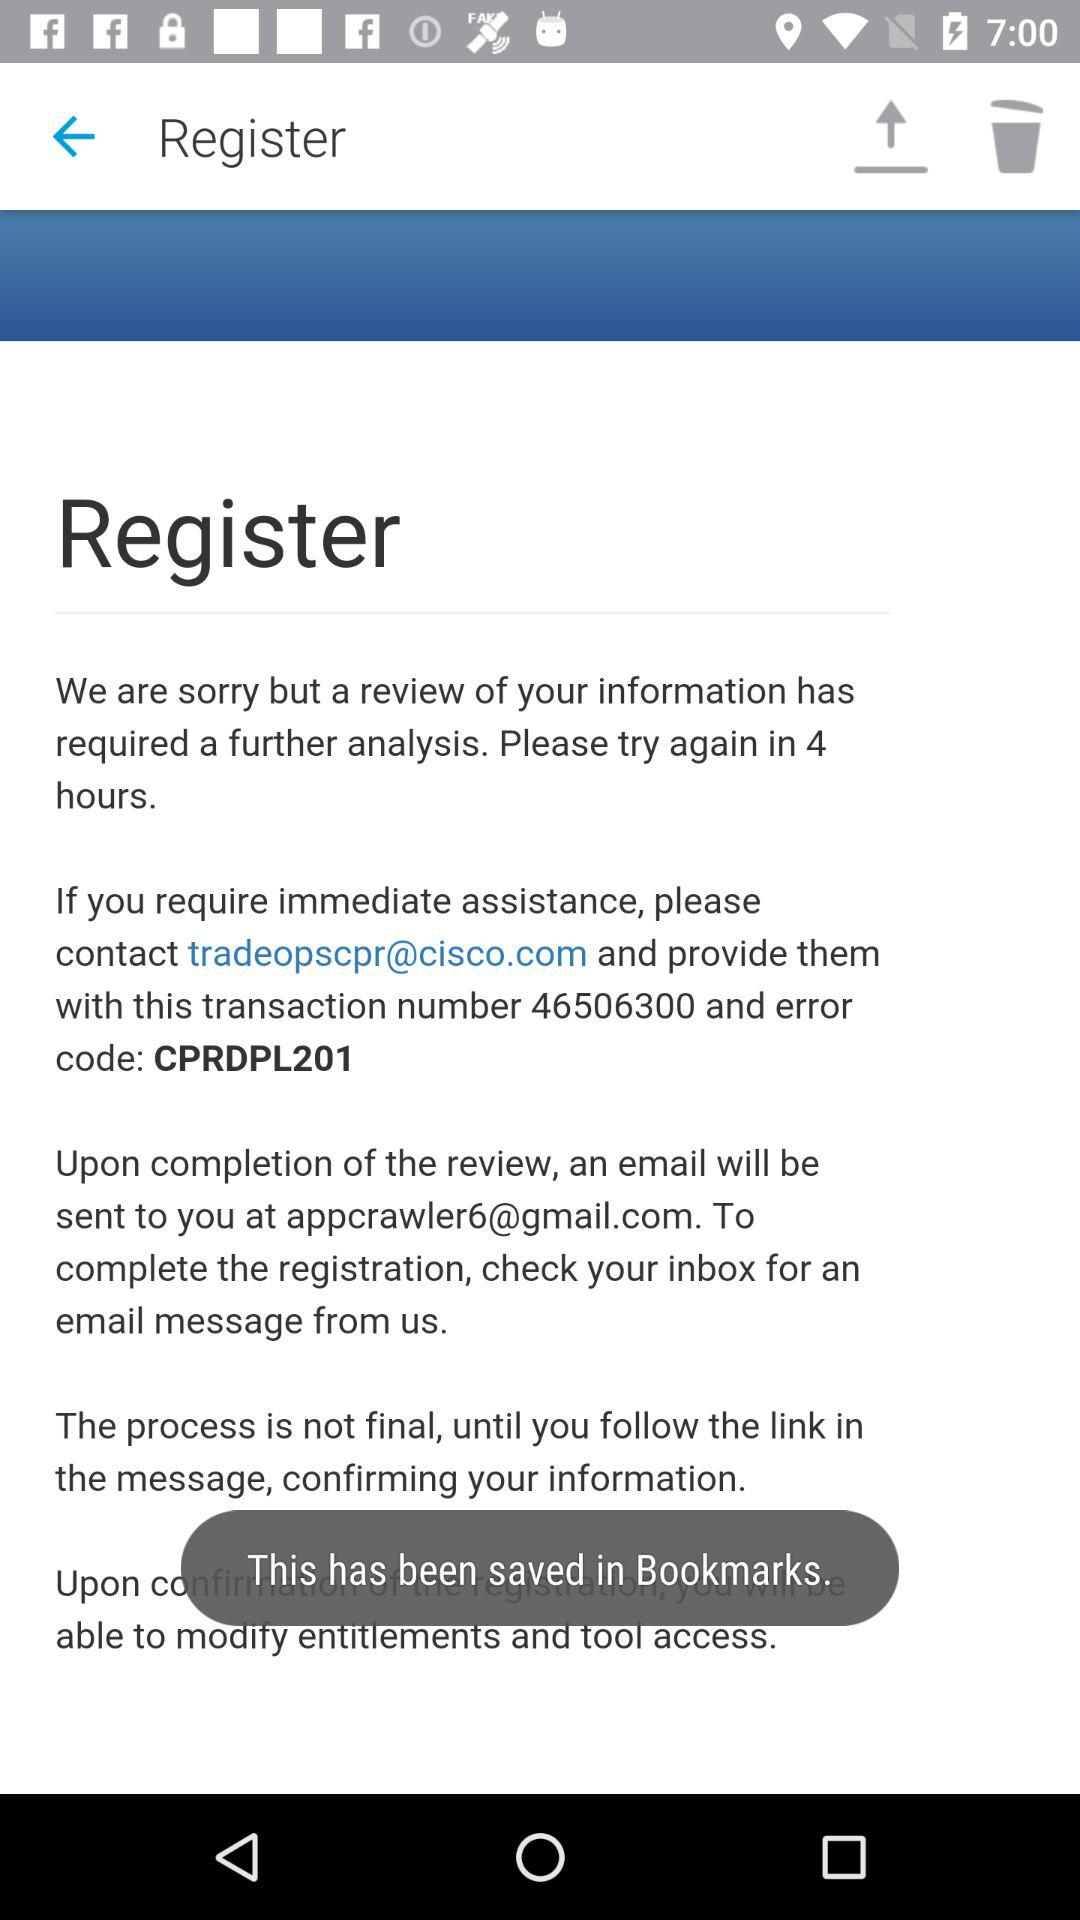What is the transaction number? The transaction number is 46506300. 